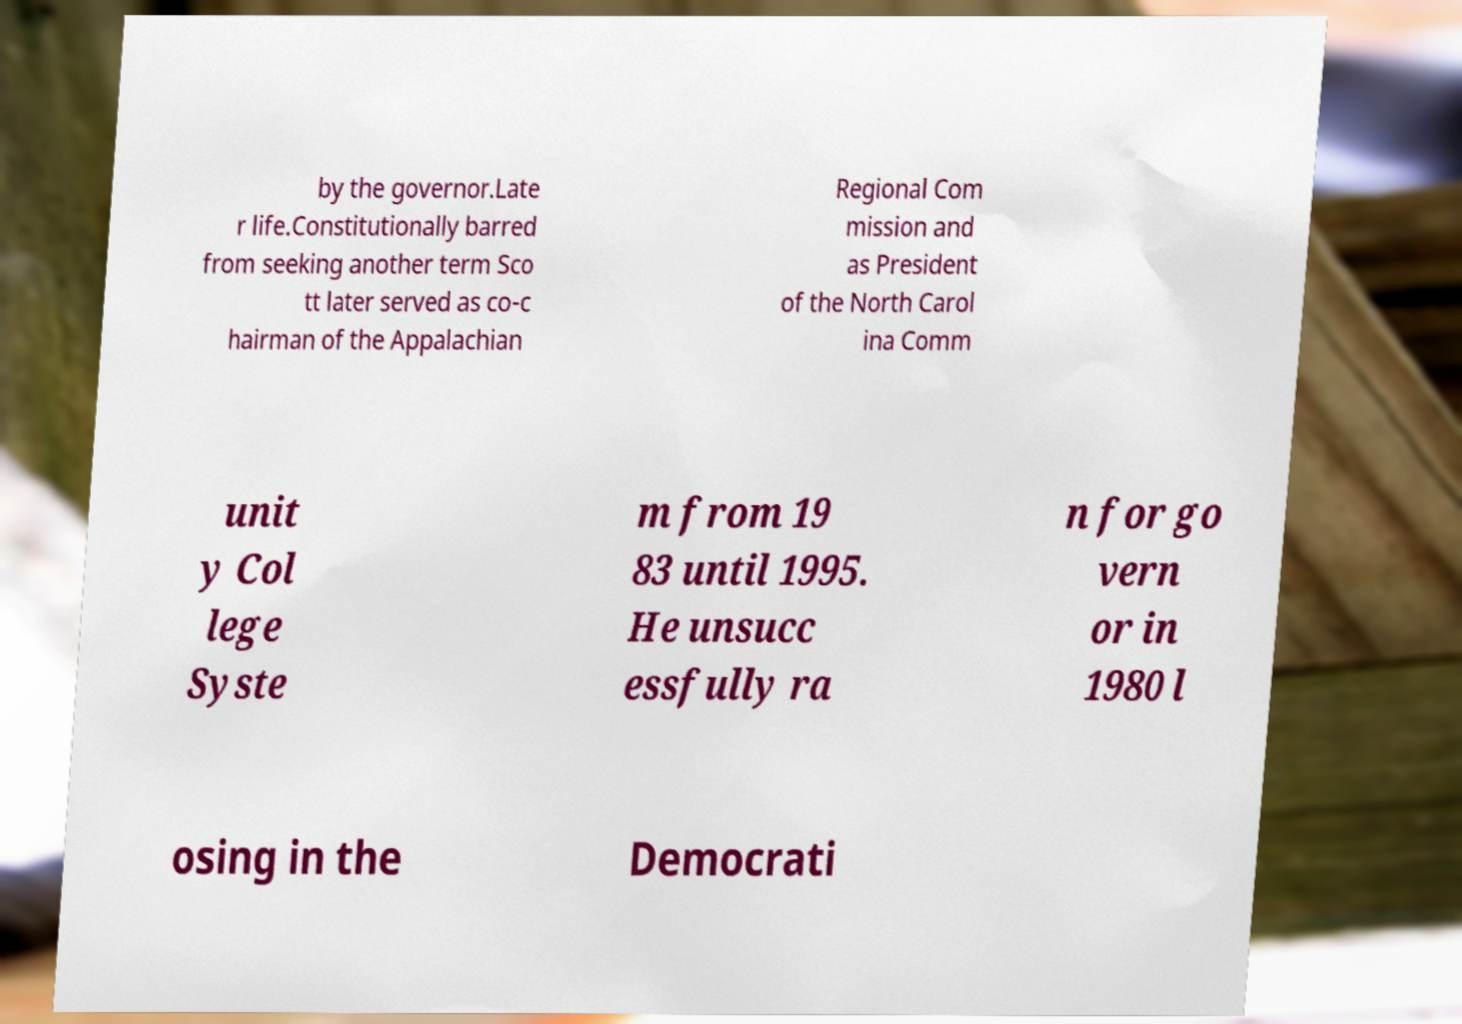There's text embedded in this image that I need extracted. Can you transcribe it verbatim? by the governor.Late r life.Constitutionally barred from seeking another term Sco tt later served as co-c hairman of the Appalachian Regional Com mission and as President of the North Carol ina Comm unit y Col lege Syste m from 19 83 until 1995. He unsucc essfully ra n for go vern or in 1980 l osing in the Democrati 